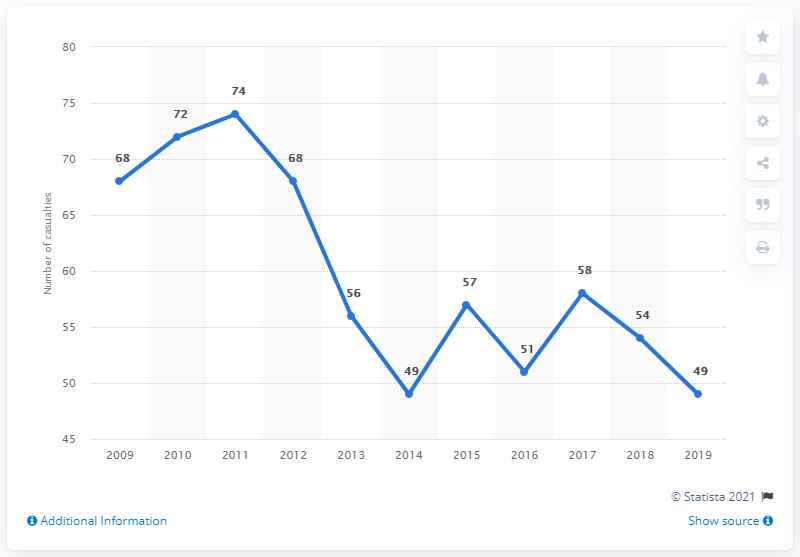Specify some key components in this picture. In 2019, 49 pedestrians lost their lives in road accidents in the Netherlands. 